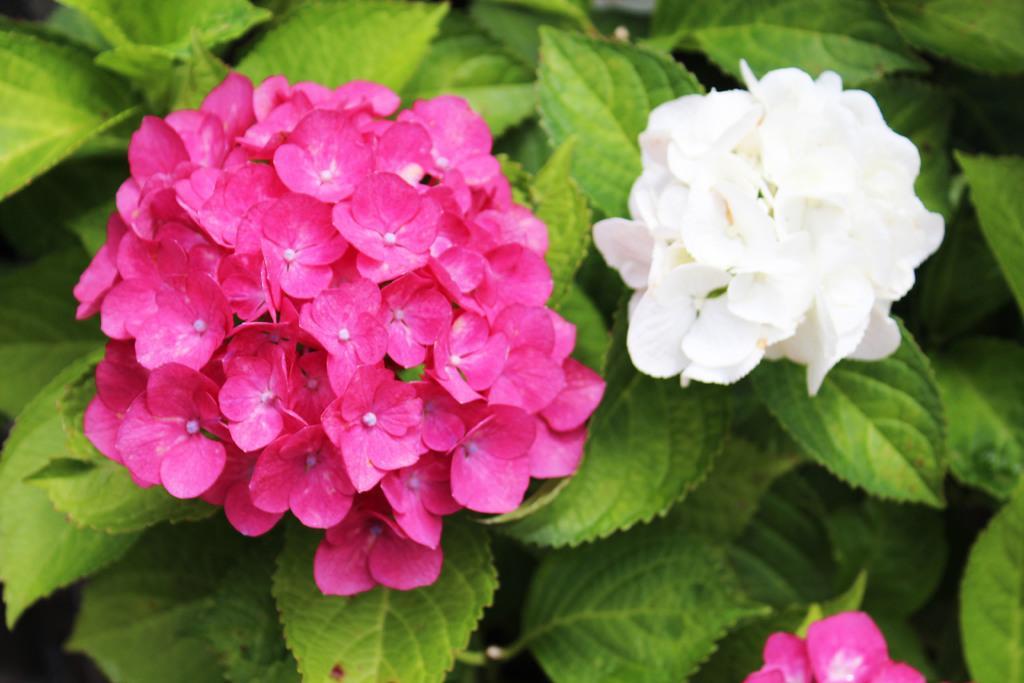Can you describe this image briefly? In this image we can see flowers and there are leaves. 